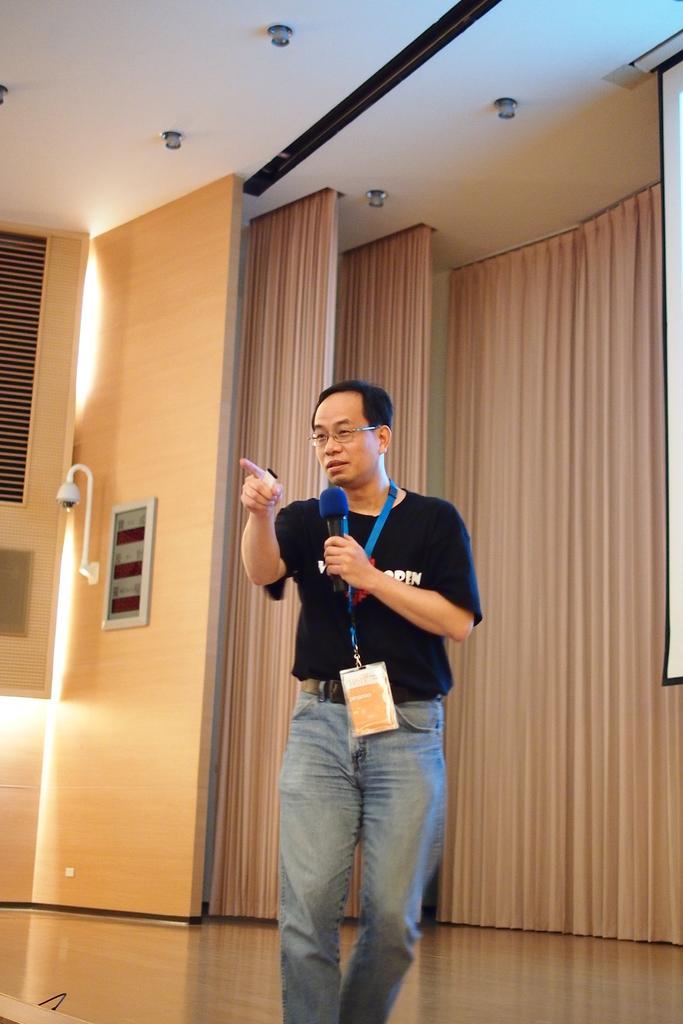Can you describe this image briefly? In this image I can see in the middle a man is standing and speaking in the microphone, he wore black color t-shirt, blue color jeans and an Id card behind him there are wooden doors. At the top there are ceiling lights. 